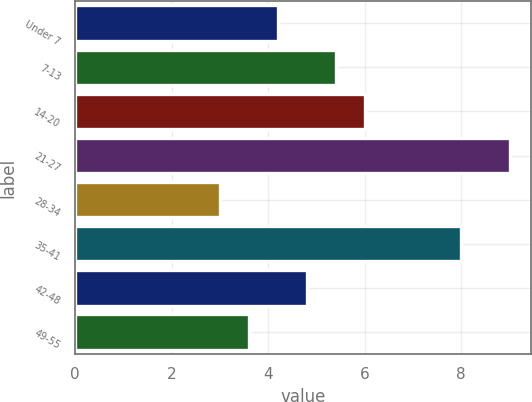Convert chart to OTSL. <chart><loc_0><loc_0><loc_500><loc_500><bar_chart><fcel>Under 7<fcel>7-13<fcel>14-20<fcel>21-27<fcel>28-34<fcel>35-41<fcel>42-48<fcel>49-55<nl><fcel>4.2<fcel>5.4<fcel>6<fcel>9<fcel>3<fcel>8<fcel>4.8<fcel>3.6<nl></chart> 